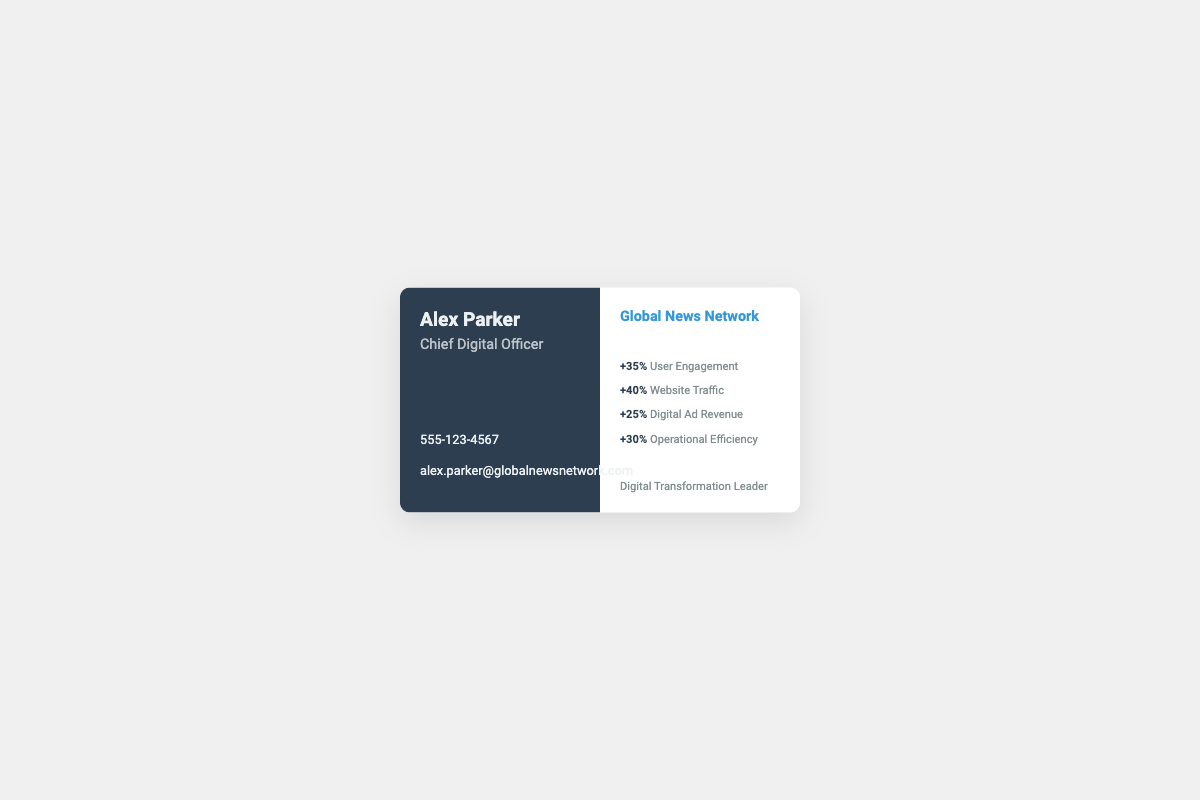What is the name of the Chief Digital Officer? The document specifies the name of the Chief Digital Officer as Alex Parker.
Answer: Alex Parker What is the contact number provided? The business card includes the contact number as 555-123-4567.
Answer: 555-123-4567 What percentage increase is noted in user engagement? The business card states a +35% increase in user engagement.
Answer: +35% What organization does Alex Parker represent? The document shows that Alex Parker is associated with Global News Network.
Answer: Global News Network What is the increase in website traffic? The metrics display a +40% increase in website traffic.
Answer: +40% What is one of the key roles mentioned in the document? The card highlights the role of Digital Transformation Leader.
Answer: Digital Transformation Leader What is the percentage increase in digital ad revenue? According to the metrics, the increase in digital ad revenue is +25%.
Answer: +25% What is the increase in operational efficiency? The document indicates a +30% increase in operational efficiency.
Answer: +30% What is the primary color of the left side of the business card? The left side of the business card is colored dark blue, specifically #2c3e50.
Answer: Dark blue 